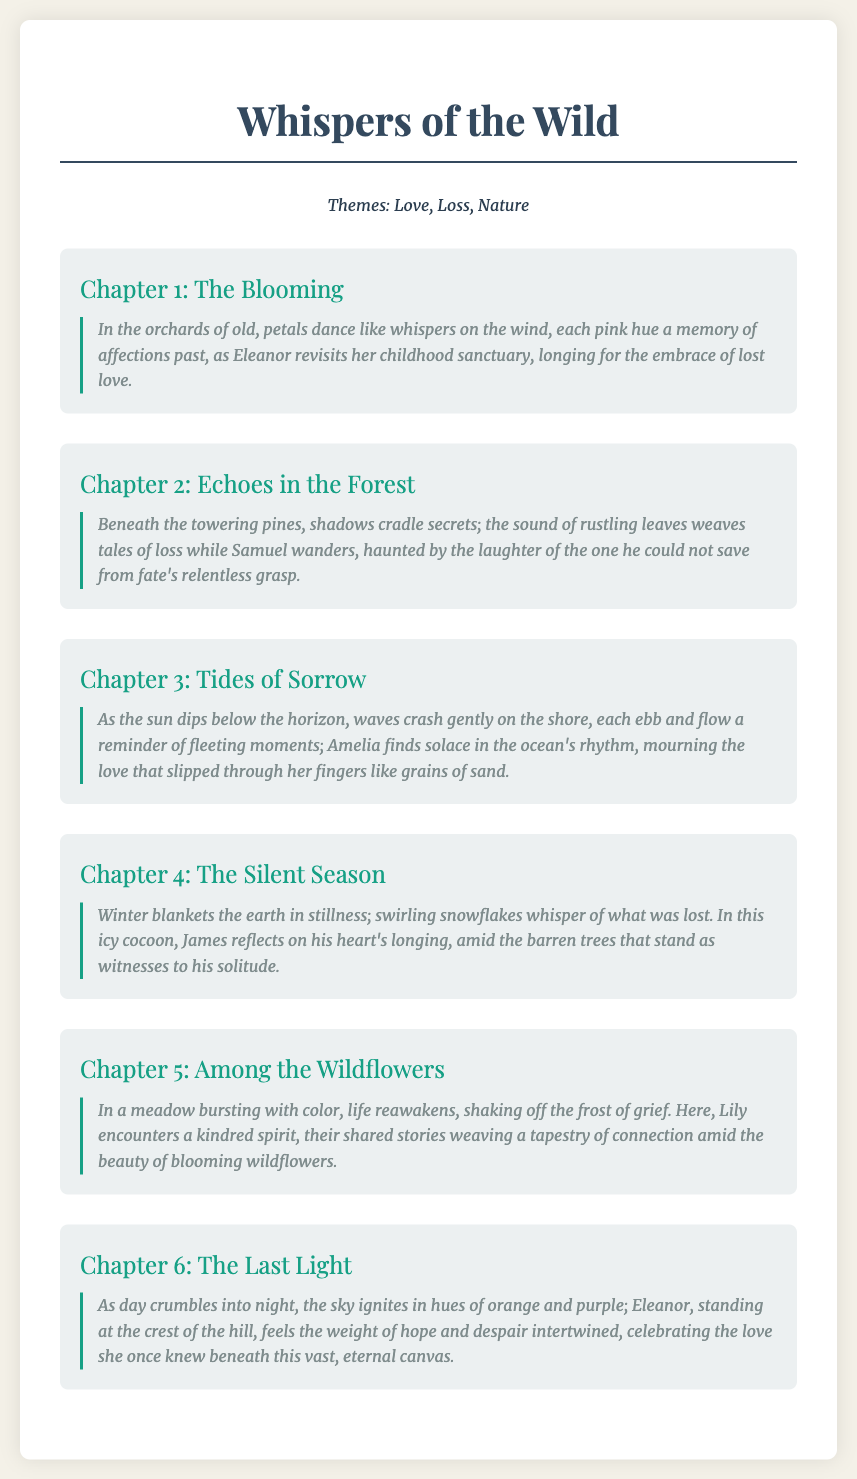What is the title of the novel? The title is found in the header of the document.
Answer: Whispers of the Wild How many chapters are in the novel outline? The number of chapters can be counted in the document.
Answer: 6 What theme is not mentioned in the document? The themes listed are specifically stated in the themes section.
Answer: Friendship What chapter focuses on a character named Eleanor? The character's name is mentioned in the description of the chapter.
Answer: Chapter 1: The Blooming Which chapter includes nature imagery related to the ocean? The chapter's focus on the ocean is explicitly described in the paragraph.
Answer: Chapter 3: Tides of Sorrow What color is predominantly associated with winter in Chapter 4? The chapter's description provides an indication of the season's color.
Answer: White 